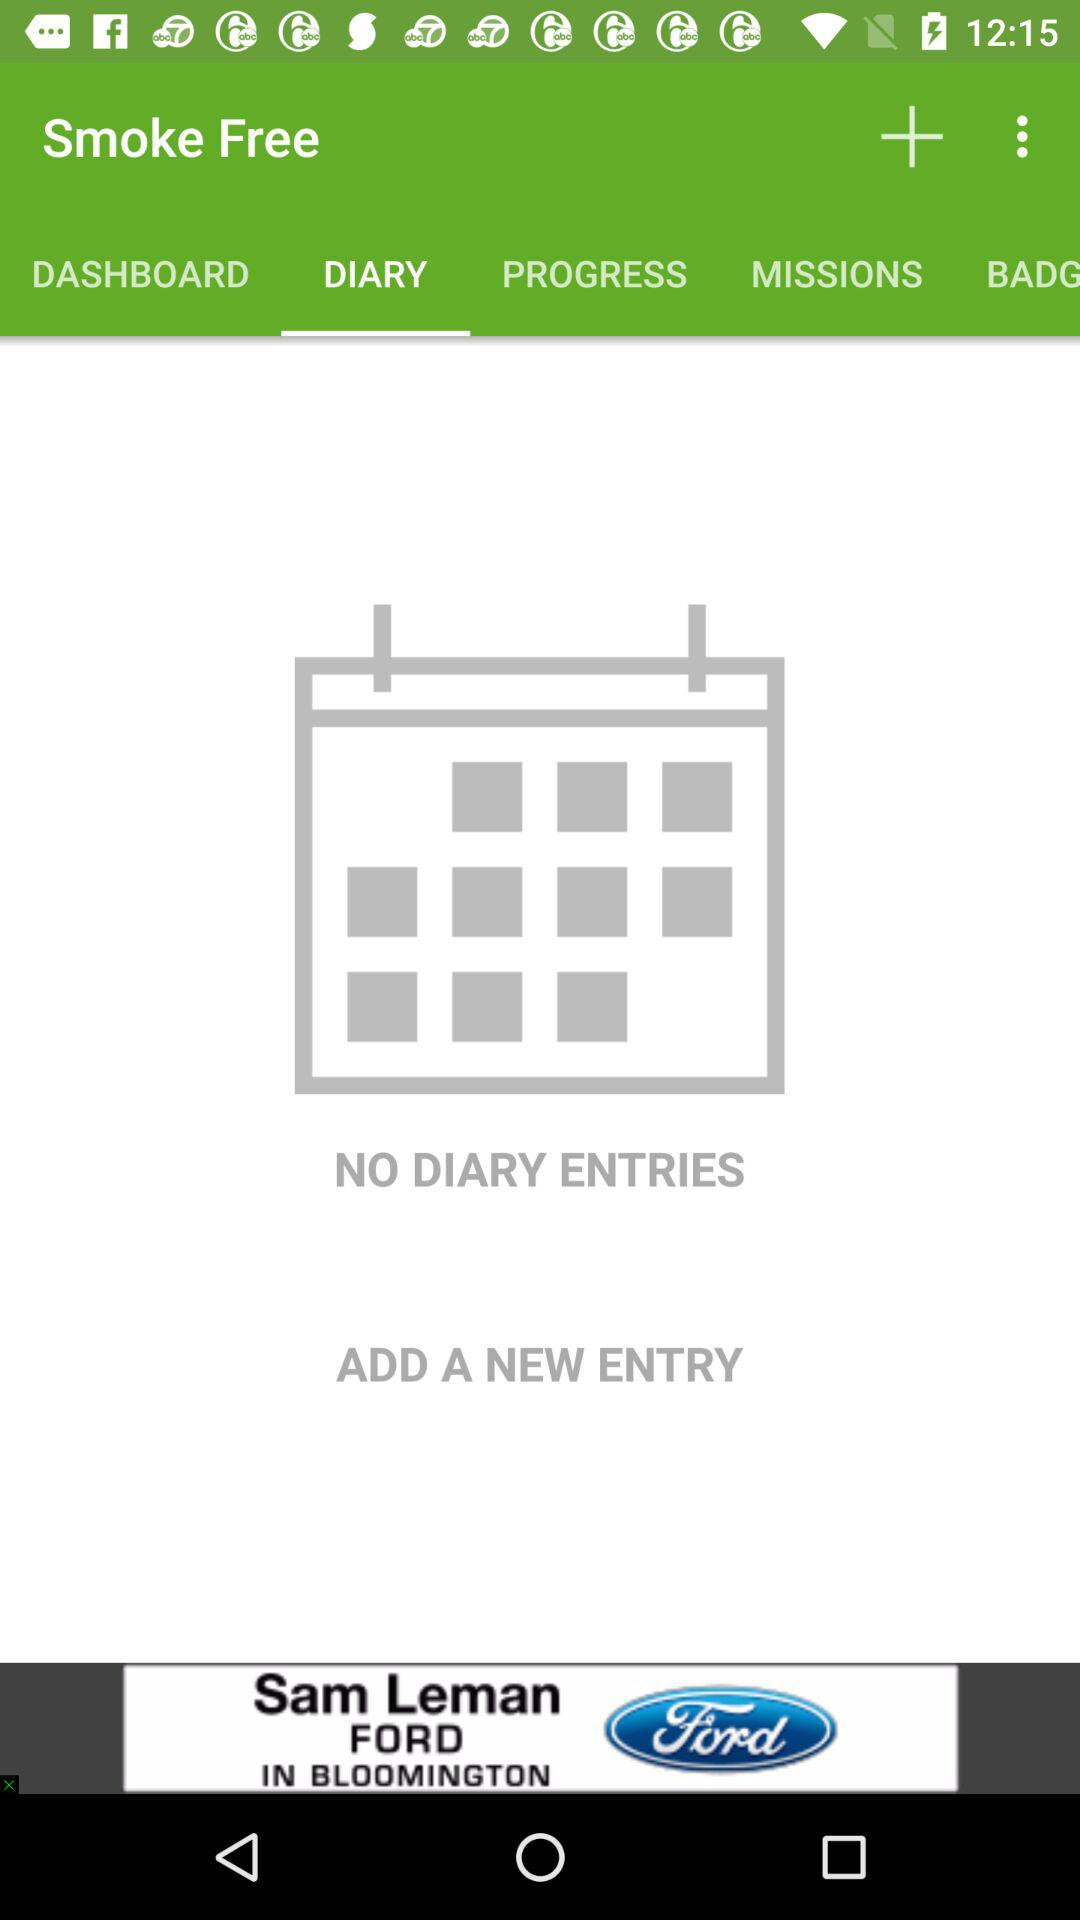Which tab has been selected? The selected tab is "DIARY". 